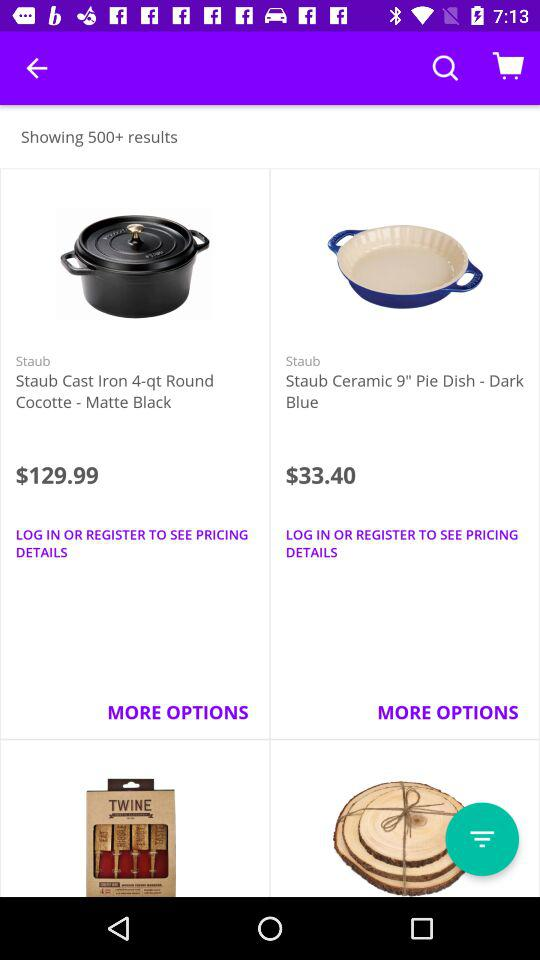What's the price of "Staub Ceramic 9" Pie Dish - Dark Blue"? The price of "Staub Ceramic 9" Pie Dish - Dark Blue" is $33.40. 